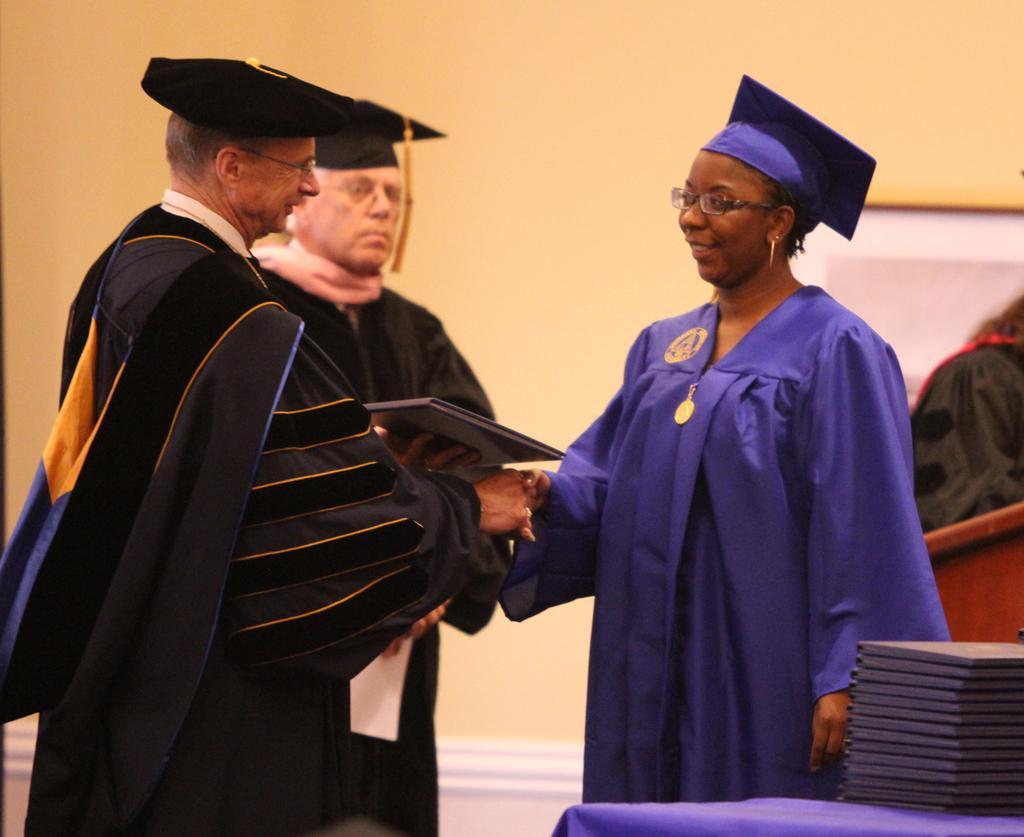Can you describe this image briefly? In this image, we can see people wearing coats and hats and we can see some books placed on the table and there is a wall. 